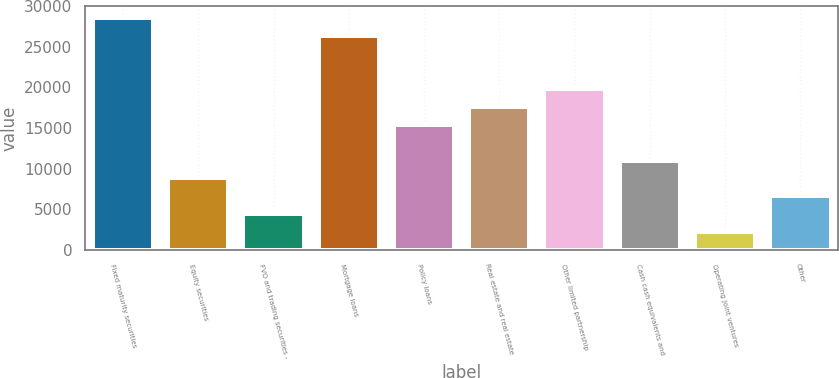Convert chart. <chart><loc_0><loc_0><loc_500><loc_500><bar_chart><fcel>Fixed maturity securities<fcel>Equity securities<fcel>FVO and trading securities -<fcel>Mortgage loans<fcel>Policy loans<fcel>Real estate and real estate<fcel>Other limited partnership<fcel>Cash cash equivalents and<fcel>Operating joint ventures<fcel>Other<nl><fcel>28578<fcel>8796<fcel>4400<fcel>26380<fcel>15390<fcel>17588<fcel>19786<fcel>10994<fcel>2202<fcel>6598<nl></chart> 